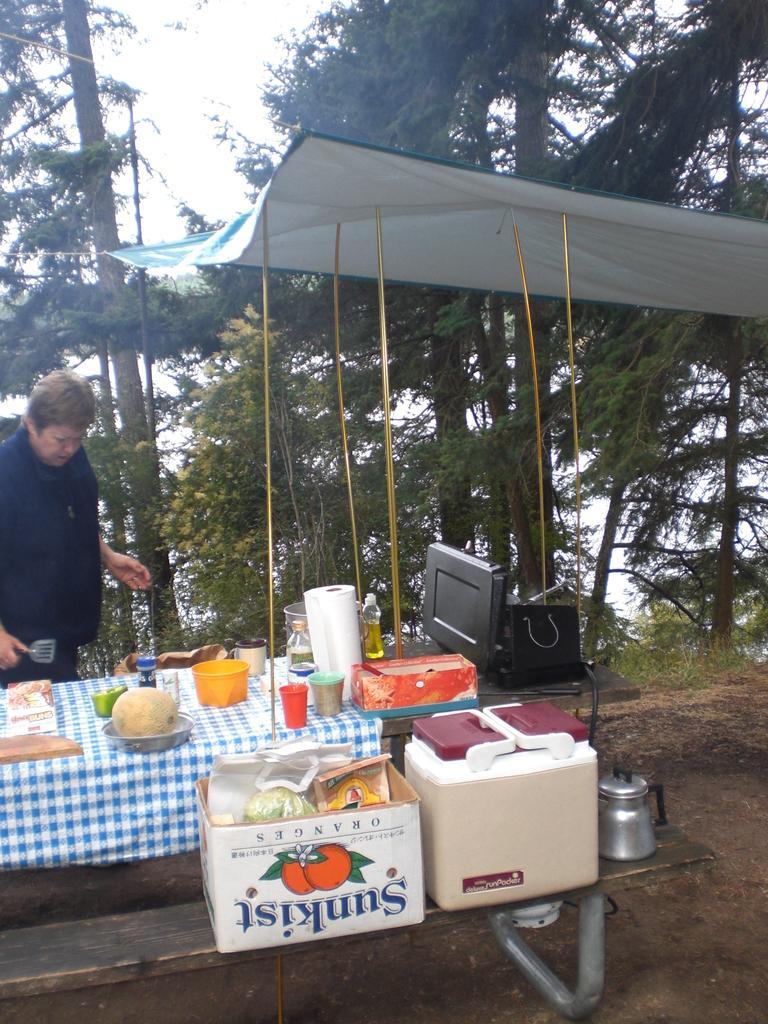Could you give a brief overview of what you see in this image? In the picture I can see a woman is standing and holding an object. Here I can see a table which has food items, glasses and other objects on it. I can also see some boxes and other objects on wooden surface. In the background I can see trees and the sky. 